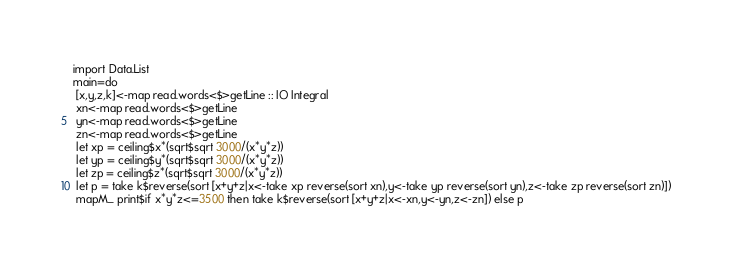<code> <loc_0><loc_0><loc_500><loc_500><_Haskell_>import Data.List
main=do
 [x,y,z,k]<-map read.words<$>getLine :: IO Integral
 xn<-map read.words<$>getLine
 yn<-map read.words<$>getLine
 zn<-map read.words<$>getLine
 let xp = ceiling$x*(sqrt$sqrt 3000/(x*y*z))
 let yp = ceiling$y*(sqrt$sqrt 3000/(x*y*z))
 let zp = ceiling$z*(sqrt$sqrt 3000/(x*y*z))
 let p = take k$reverse(sort [x+y+z|x<-take xp reverse(sort xn),y<-take yp reverse(sort yn),z<-take zp reverse(sort zn)])
 mapM_ print$if x*y*z<=3500 then take k$reverse(sort [x+y+z|x<-xn,y<-yn,z<-zn]) else p</code> 